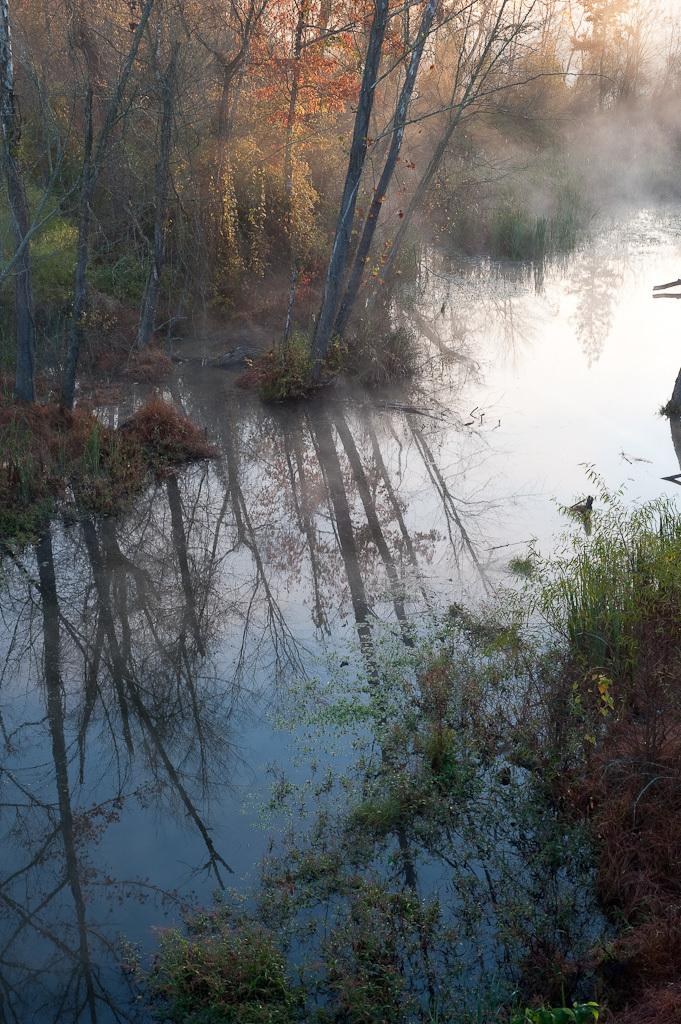What type of vegetation is at the bottom of the image? There is river grass and plants at the bottom of the image. What can be seen in the background of the image? There are trees in the background of the image. What reason does the river grass have for growing in the image? The river grass does not have a reason for growing in the image; it is simply present in the scene. What effect does the presence of plants at the bottom of the image have on the overall composition? The presence of plants at the bottom of the image contributes to the natural setting and adds visual interest to the scene. 